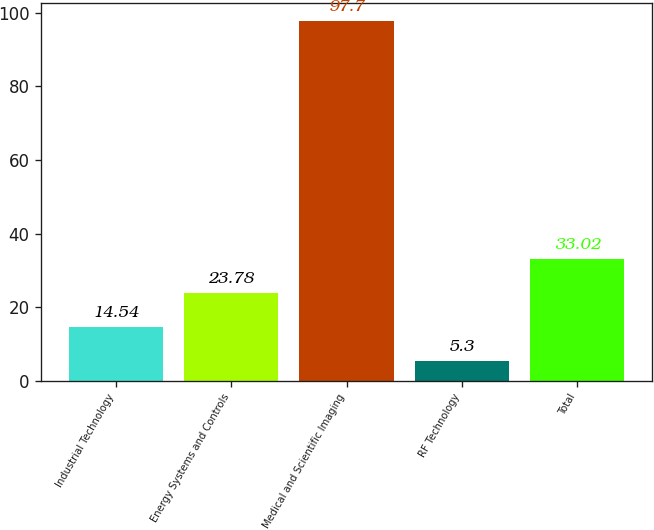Convert chart. <chart><loc_0><loc_0><loc_500><loc_500><bar_chart><fcel>Industrial Technology<fcel>Energy Systems and Controls<fcel>Medical and Scientific Imaging<fcel>RF Technology<fcel>Total<nl><fcel>14.54<fcel>23.78<fcel>97.7<fcel>5.3<fcel>33.02<nl></chart> 